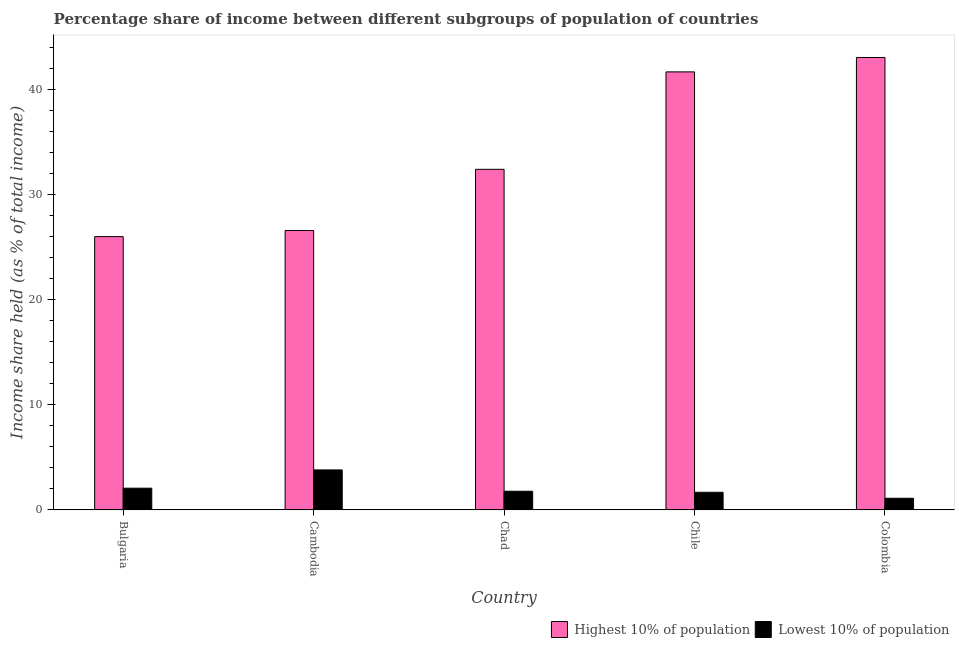How many different coloured bars are there?
Make the answer very short. 2. Are the number of bars on each tick of the X-axis equal?
Your response must be concise. Yes. In how many cases, is the number of bars for a given country not equal to the number of legend labels?
Provide a short and direct response. 0. What is the income share held by lowest 10% of the population in Chile?
Your answer should be very brief. 1.68. Across all countries, what is the maximum income share held by lowest 10% of the population?
Offer a very short reply. 3.81. Across all countries, what is the minimum income share held by lowest 10% of the population?
Your answer should be compact. 1.11. In which country was the income share held by lowest 10% of the population maximum?
Offer a terse response. Cambodia. In which country was the income share held by lowest 10% of the population minimum?
Ensure brevity in your answer.  Colombia. What is the total income share held by highest 10% of the population in the graph?
Make the answer very short. 169.89. What is the difference between the income share held by lowest 10% of the population in Chad and that in Chile?
Your response must be concise. 0.1. What is the difference between the income share held by highest 10% of the population in Cambodia and the income share held by lowest 10% of the population in Chad?
Offer a very short reply. 24.83. What is the average income share held by lowest 10% of the population per country?
Offer a very short reply. 2.09. What is the difference between the income share held by highest 10% of the population and income share held by lowest 10% of the population in Chad?
Offer a very short reply. 30.66. In how many countries, is the income share held by highest 10% of the population greater than 42 %?
Offer a terse response. 1. What is the ratio of the income share held by lowest 10% of the population in Chad to that in Colombia?
Give a very brief answer. 1.6. What is the difference between the highest and the second highest income share held by highest 10% of the population?
Give a very brief answer. 1.37. What is the difference between the highest and the lowest income share held by highest 10% of the population?
Offer a terse response. 17.06. In how many countries, is the income share held by lowest 10% of the population greater than the average income share held by lowest 10% of the population taken over all countries?
Provide a short and direct response. 1. What does the 1st bar from the left in Cambodia represents?
Keep it short and to the point. Highest 10% of population. What does the 1st bar from the right in Chad represents?
Provide a short and direct response. Lowest 10% of population. How many bars are there?
Give a very brief answer. 10. Are all the bars in the graph horizontal?
Your answer should be compact. No. How many countries are there in the graph?
Provide a succinct answer. 5. Are the values on the major ticks of Y-axis written in scientific E-notation?
Your response must be concise. No. Does the graph contain any zero values?
Offer a very short reply. No. How many legend labels are there?
Offer a terse response. 2. What is the title of the graph?
Offer a very short reply. Percentage share of income between different subgroups of population of countries. Does "Private creditors" appear as one of the legend labels in the graph?
Keep it short and to the point. No. What is the label or title of the Y-axis?
Make the answer very short. Income share held (as % of total income). What is the Income share held (as % of total income) of Highest 10% of population in Bulgaria?
Offer a terse response. 26.03. What is the Income share held (as % of total income) in Lowest 10% of population in Bulgaria?
Offer a terse response. 2.07. What is the Income share held (as % of total income) of Highest 10% of population in Cambodia?
Offer a terse response. 26.61. What is the Income share held (as % of total income) of Lowest 10% of population in Cambodia?
Your response must be concise. 3.81. What is the Income share held (as % of total income) of Highest 10% of population in Chad?
Your answer should be compact. 32.44. What is the Income share held (as % of total income) in Lowest 10% of population in Chad?
Your answer should be very brief. 1.78. What is the Income share held (as % of total income) in Highest 10% of population in Chile?
Offer a very short reply. 41.72. What is the Income share held (as % of total income) of Lowest 10% of population in Chile?
Provide a succinct answer. 1.68. What is the Income share held (as % of total income) of Highest 10% of population in Colombia?
Provide a succinct answer. 43.09. What is the Income share held (as % of total income) in Lowest 10% of population in Colombia?
Your answer should be compact. 1.11. Across all countries, what is the maximum Income share held (as % of total income) in Highest 10% of population?
Your answer should be compact. 43.09. Across all countries, what is the maximum Income share held (as % of total income) of Lowest 10% of population?
Your answer should be compact. 3.81. Across all countries, what is the minimum Income share held (as % of total income) in Highest 10% of population?
Provide a succinct answer. 26.03. Across all countries, what is the minimum Income share held (as % of total income) of Lowest 10% of population?
Keep it short and to the point. 1.11. What is the total Income share held (as % of total income) in Highest 10% of population in the graph?
Offer a terse response. 169.89. What is the total Income share held (as % of total income) in Lowest 10% of population in the graph?
Provide a succinct answer. 10.45. What is the difference between the Income share held (as % of total income) of Highest 10% of population in Bulgaria and that in Cambodia?
Make the answer very short. -0.58. What is the difference between the Income share held (as % of total income) in Lowest 10% of population in Bulgaria and that in Cambodia?
Provide a short and direct response. -1.74. What is the difference between the Income share held (as % of total income) of Highest 10% of population in Bulgaria and that in Chad?
Provide a short and direct response. -6.41. What is the difference between the Income share held (as % of total income) in Lowest 10% of population in Bulgaria and that in Chad?
Provide a succinct answer. 0.29. What is the difference between the Income share held (as % of total income) in Highest 10% of population in Bulgaria and that in Chile?
Offer a very short reply. -15.69. What is the difference between the Income share held (as % of total income) of Lowest 10% of population in Bulgaria and that in Chile?
Make the answer very short. 0.39. What is the difference between the Income share held (as % of total income) of Highest 10% of population in Bulgaria and that in Colombia?
Your response must be concise. -17.06. What is the difference between the Income share held (as % of total income) of Highest 10% of population in Cambodia and that in Chad?
Offer a terse response. -5.83. What is the difference between the Income share held (as % of total income) of Lowest 10% of population in Cambodia and that in Chad?
Provide a succinct answer. 2.03. What is the difference between the Income share held (as % of total income) of Highest 10% of population in Cambodia and that in Chile?
Your answer should be very brief. -15.11. What is the difference between the Income share held (as % of total income) of Lowest 10% of population in Cambodia and that in Chile?
Offer a very short reply. 2.13. What is the difference between the Income share held (as % of total income) in Highest 10% of population in Cambodia and that in Colombia?
Your answer should be compact. -16.48. What is the difference between the Income share held (as % of total income) of Highest 10% of population in Chad and that in Chile?
Give a very brief answer. -9.28. What is the difference between the Income share held (as % of total income) in Lowest 10% of population in Chad and that in Chile?
Offer a very short reply. 0.1. What is the difference between the Income share held (as % of total income) of Highest 10% of population in Chad and that in Colombia?
Your response must be concise. -10.65. What is the difference between the Income share held (as % of total income) of Lowest 10% of population in Chad and that in Colombia?
Provide a succinct answer. 0.67. What is the difference between the Income share held (as % of total income) in Highest 10% of population in Chile and that in Colombia?
Your answer should be very brief. -1.37. What is the difference between the Income share held (as % of total income) in Lowest 10% of population in Chile and that in Colombia?
Keep it short and to the point. 0.57. What is the difference between the Income share held (as % of total income) of Highest 10% of population in Bulgaria and the Income share held (as % of total income) of Lowest 10% of population in Cambodia?
Ensure brevity in your answer.  22.22. What is the difference between the Income share held (as % of total income) of Highest 10% of population in Bulgaria and the Income share held (as % of total income) of Lowest 10% of population in Chad?
Your response must be concise. 24.25. What is the difference between the Income share held (as % of total income) of Highest 10% of population in Bulgaria and the Income share held (as % of total income) of Lowest 10% of population in Chile?
Make the answer very short. 24.35. What is the difference between the Income share held (as % of total income) of Highest 10% of population in Bulgaria and the Income share held (as % of total income) of Lowest 10% of population in Colombia?
Give a very brief answer. 24.92. What is the difference between the Income share held (as % of total income) of Highest 10% of population in Cambodia and the Income share held (as % of total income) of Lowest 10% of population in Chad?
Your response must be concise. 24.83. What is the difference between the Income share held (as % of total income) in Highest 10% of population in Cambodia and the Income share held (as % of total income) in Lowest 10% of population in Chile?
Provide a short and direct response. 24.93. What is the difference between the Income share held (as % of total income) of Highest 10% of population in Chad and the Income share held (as % of total income) of Lowest 10% of population in Chile?
Give a very brief answer. 30.76. What is the difference between the Income share held (as % of total income) in Highest 10% of population in Chad and the Income share held (as % of total income) in Lowest 10% of population in Colombia?
Provide a succinct answer. 31.33. What is the difference between the Income share held (as % of total income) of Highest 10% of population in Chile and the Income share held (as % of total income) of Lowest 10% of population in Colombia?
Provide a succinct answer. 40.61. What is the average Income share held (as % of total income) of Highest 10% of population per country?
Make the answer very short. 33.98. What is the average Income share held (as % of total income) of Lowest 10% of population per country?
Offer a very short reply. 2.09. What is the difference between the Income share held (as % of total income) in Highest 10% of population and Income share held (as % of total income) in Lowest 10% of population in Bulgaria?
Keep it short and to the point. 23.96. What is the difference between the Income share held (as % of total income) of Highest 10% of population and Income share held (as % of total income) of Lowest 10% of population in Cambodia?
Provide a succinct answer. 22.8. What is the difference between the Income share held (as % of total income) of Highest 10% of population and Income share held (as % of total income) of Lowest 10% of population in Chad?
Ensure brevity in your answer.  30.66. What is the difference between the Income share held (as % of total income) in Highest 10% of population and Income share held (as % of total income) in Lowest 10% of population in Chile?
Provide a short and direct response. 40.04. What is the difference between the Income share held (as % of total income) in Highest 10% of population and Income share held (as % of total income) in Lowest 10% of population in Colombia?
Your answer should be very brief. 41.98. What is the ratio of the Income share held (as % of total income) in Highest 10% of population in Bulgaria to that in Cambodia?
Ensure brevity in your answer.  0.98. What is the ratio of the Income share held (as % of total income) in Lowest 10% of population in Bulgaria to that in Cambodia?
Make the answer very short. 0.54. What is the ratio of the Income share held (as % of total income) of Highest 10% of population in Bulgaria to that in Chad?
Your answer should be very brief. 0.8. What is the ratio of the Income share held (as % of total income) in Lowest 10% of population in Bulgaria to that in Chad?
Provide a short and direct response. 1.16. What is the ratio of the Income share held (as % of total income) of Highest 10% of population in Bulgaria to that in Chile?
Make the answer very short. 0.62. What is the ratio of the Income share held (as % of total income) in Lowest 10% of population in Bulgaria to that in Chile?
Ensure brevity in your answer.  1.23. What is the ratio of the Income share held (as % of total income) of Highest 10% of population in Bulgaria to that in Colombia?
Provide a short and direct response. 0.6. What is the ratio of the Income share held (as % of total income) in Lowest 10% of population in Bulgaria to that in Colombia?
Your answer should be very brief. 1.86. What is the ratio of the Income share held (as % of total income) in Highest 10% of population in Cambodia to that in Chad?
Ensure brevity in your answer.  0.82. What is the ratio of the Income share held (as % of total income) of Lowest 10% of population in Cambodia to that in Chad?
Your answer should be very brief. 2.14. What is the ratio of the Income share held (as % of total income) in Highest 10% of population in Cambodia to that in Chile?
Provide a short and direct response. 0.64. What is the ratio of the Income share held (as % of total income) of Lowest 10% of population in Cambodia to that in Chile?
Provide a short and direct response. 2.27. What is the ratio of the Income share held (as % of total income) of Highest 10% of population in Cambodia to that in Colombia?
Your answer should be very brief. 0.62. What is the ratio of the Income share held (as % of total income) of Lowest 10% of population in Cambodia to that in Colombia?
Your response must be concise. 3.43. What is the ratio of the Income share held (as % of total income) in Highest 10% of population in Chad to that in Chile?
Make the answer very short. 0.78. What is the ratio of the Income share held (as % of total income) in Lowest 10% of population in Chad to that in Chile?
Make the answer very short. 1.06. What is the ratio of the Income share held (as % of total income) in Highest 10% of population in Chad to that in Colombia?
Offer a very short reply. 0.75. What is the ratio of the Income share held (as % of total income) in Lowest 10% of population in Chad to that in Colombia?
Ensure brevity in your answer.  1.6. What is the ratio of the Income share held (as % of total income) in Highest 10% of population in Chile to that in Colombia?
Offer a very short reply. 0.97. What is the ratio of the Income share held (as % of total income) of Lowest 10% of population in Chile to that in Colombia?
Make the answer very short. 1.51. What is the difference between the highest and the second highest Income share held (as % of total income) in Highest 10% of population?
Provide a short and direct response. 1.37. What is the difference between the highest and the second highest Income share held (as % of total income) in Lowest 10% of population?
Offer a very short reply. 1.74. What is the difference between the highest and the lowest Income share held (as % of total income) in Highest 10% of population?
Provide a succinct answer. 17.06. What is the difference between the highest and the lowest Income share held (as % of total income) of Lowest 10% of population?
Provide a succinct answer. 2.7. 